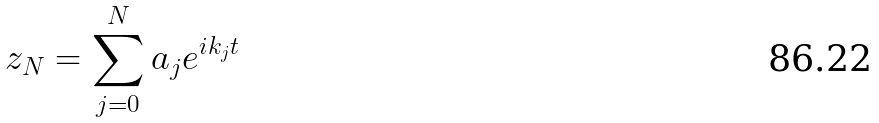Convert formula to latex. <formula><loc_0><loc_0><loc_500><loc_500>z _ { N } = \sum _ { j = 0 } ^ { N } a _ { j } e ^ { i k _ { j } t }</formula> 